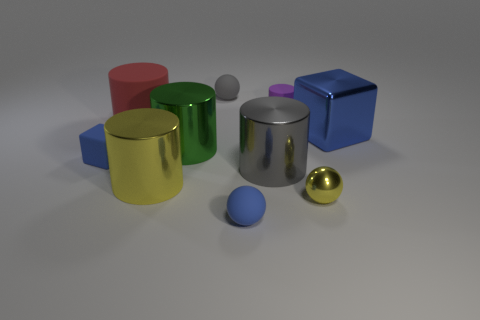What number of yellow things have the same material as the large green cylinder?
Provide a short and direct response. 2. Is the material of the small cylinder the same as the blue object that is behind the large green metallic cylinder?
Your answer should be compact. No. What number of objects are cylinders in front of the big blue object or small red metal cubes?
Give a very brief answer. 3. What is the size of the yellow metallic object right of the large gray shiny object behind the small matte ball that is in front of the small blue cube?
Provide a short and direct response. Small. There is another tiny block that is the same color as the metal cube; what material is it?
Provide a short and direct response. Rubber. Are there any other things that have the same shape as the large gray object?
Keep it short and to the point. Yes. What size is the block right of the yellow ball that is right of the large green thing?
Provide a short and direct response. Large. What number of big objects are either green metal things or matte cubes?
Your answer should be compact. 1. Is the number of purple rubber spheres less than the number of green things?
Your answer should be compact. Yes. Is there any other thing that is the same size as the yellow metal cylinder?
Your answer should be very brief. Yes. 